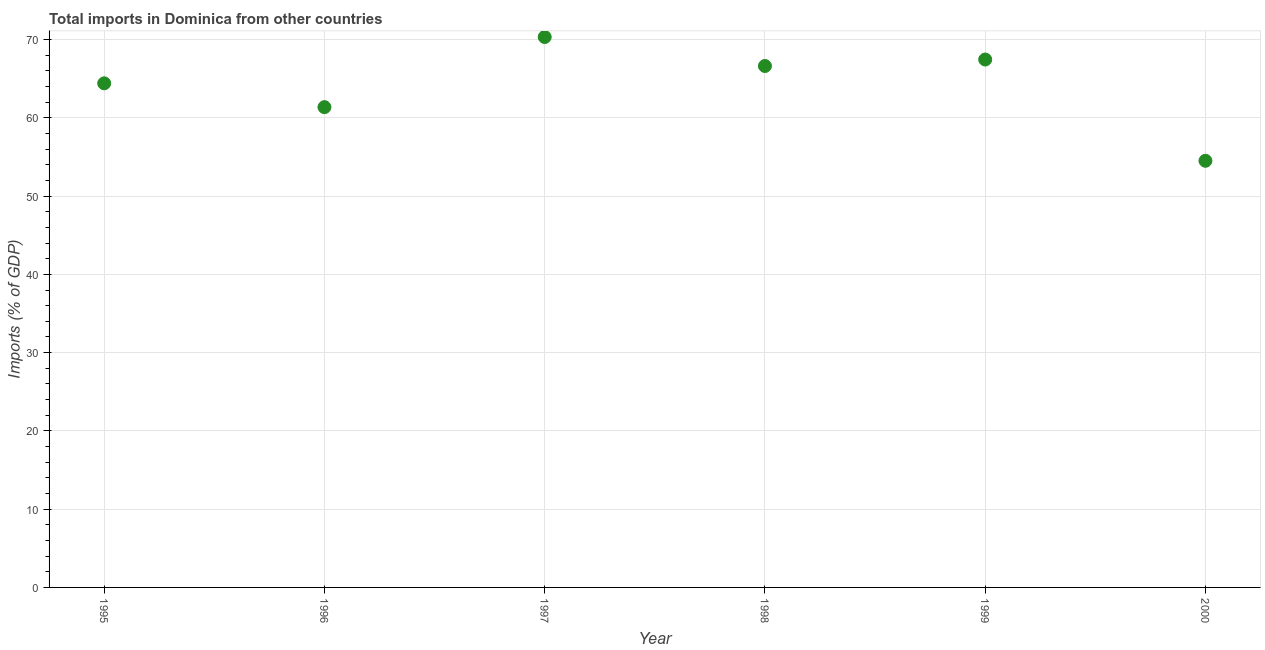What is the total imports in 1995?
Keep it short and to the point. 64.41. Across all years, what is the maximum total imports?
Your answer should be very brief. 70.33. Across all years, what is the minimum total imports?
Offer a very short reply. 54.51. In which year was the total imports minimum?
Make the answer very short. 2000. What is the sum of the total imports?
Provide a succinct answer. 384.69. What is the difference between the total imports in 1996 and 2000?
Your answer should be compact. 6.86. What is the average total imports per year?
Your response must be concise. 64.12. What is the median total imports?
Provide a succinct answer. 65.52. What is the ratio of the total imports in 1998 to that in 2000?
Give a very brief answer. 1.22. Is the total imports in 1995 less than that in 1998?
Provide a succinct answer. Yes. What is the difference between the highest and the second highest total imports?
Your answer should be very brief. 2.88. Is the sum of the total imports in 1996 and 2000 greater than the maximum total imports across all years?
Give a very brief answer. Yes. What is the difference between the highest and the lowest total imports?
Give a very brief answer. 15.82. How many dotlines are there?
Ensure brevity in your answer.  1. Are the values on the major ticks of Y-axis written in scientific E-notation?
Ensure brevity in your answer.  No. Does the graph contain grids?
Your answer should be very brief. Yes. What is the title of the graph?
Keep it short and to the point. Total imports in Dominica from other countries. What is the label or title of the X-axis?
Your response must be concise. Year. What is the label or title of the Y-axis?
Your answer should be compact. Imports (% of GDP). What is the Imports (% of GDP) in 1995?
Provide a succinct answer. 64.41. What is the Imports (% of GDP) in 1996?
Offer a terse response. 61.37. What is the Imports (% of GDP) in 1997?
Ensure brevity in your answer.  70.33. What is the Imports (% of GDP) in 1998?
Give a very brief answer. 66.62. What is the Imports (% of GDP) in 1999?
Provide a succinct answer. 67.45. What is the Imports (% of GDP) in 2000?
Give a very brief answer. 54.51. What is the difference between the Imports (% of GDP) in 1995 and 1996?
Your response must be concise. 3.04. What is the difference between the Imports (% of GDP) in 1995 and 1997?
Offer a very short reply. -5.92. What is the difference between the Imports (% of GDP) in 1995 and 1998?
Ensure brevity in your answer.  -2.22. What is the difference between the Imports (% of GDP) in 1995 and 1999?
Keep it short and to the point. -3.04. What is the difference between the Imports (% of GDP) in 1995 and 2000?
Your response must be concise. 9.9. What is the difference between the Imports (% of GDP) in 1996 and 1997?
Provide a succinct answer. -8.96. What is the difference between the Imports (% of GDP) in 1996 and 1998?
Your response must be concise. -5.26. What is the difference between the Imports (% of GDP) in 1996 and 1999?
Your response must be concise. -6.08. What is the difference between the Imports (% of GDP) in 1996 and 2000?
Provide a short and direct response. 6.86. What is the difference between the Imports (% of GDP) in 1997 and 1998?
Make the answer very short. 3.7. What is the difference between the Imports (% of GDP) in 1997 and 1999?
Offer a terse response. 2.88. What is the difference between the Imports (% of GDP) in 1997 and 2000?
Offer a very short reply. 15.81. What is the difference between the Imports (% of GDP) in 1998 and 1999?
Your response must be concise. -0.83. What is the difference between the Imports (% of GDP) in 1998 and 2000?
Your answer should be compact. 12.11. What is the difference between the Imports (% of GDP) in 1999 and 2000?
Make the answer very short. 12.94. What is the ratio of the Imports (% of GDP) in 1995 to that in 1997?
Provide a short and direct response. 0.92. What is the ratio of the Imports (% of GDP) in 1995 to that in 1998?
Provide a succinct answer. 0.97. What is the ratio of the Imports (% of GDP) in 1995 to that in 1999?
Provide a short and direct response. 0.95. What is the ratio of the Imports (% of GDP) in 1995 to that in 2000?
Keep it short and to the point. 1.18. What is the ratio of the Imports (% of GDP) in 1996 to that in 1997?
Provide a short and direct response. 0.87. What is the ratio of the Imports (% of GDP) in 1996 to that in 1998?
Keep it short and to the point. 0.92. What is the ratio of the Imports (% of GDP) in 1996 to that in 1999?
Provide a short and direct response. 0.91. What is the ratio of the Imports (% of GDP) in 1996 to that in 2000?
Keep it short and to the point. 1.13. What is the ratio of the Imports (% of GDP) in 1997 to that in 1998?
Provide a succinct answer. 1.06. What is the ratio of the Imports (% of GDP) in 1997 to that in 1999?
Ensure brevity in your answer.  1.04. What is the ratio of the Imports (% of GDP) in 1997 to that in 2000?
Keep it short and to the point. 1.29. What is the ratio of the Imports (% of GDP) in 1998 to that in 1999?
Provide a succinct answer. 0.99. What is the ratio of the Imports (% of GDP) in 1998 to that in 2000?
Offer a terse response. 1.22. What is the ratio of the Imports (% of GDP) in 1999 to that in 2000?
Keep it short and to the point. 1.24. 